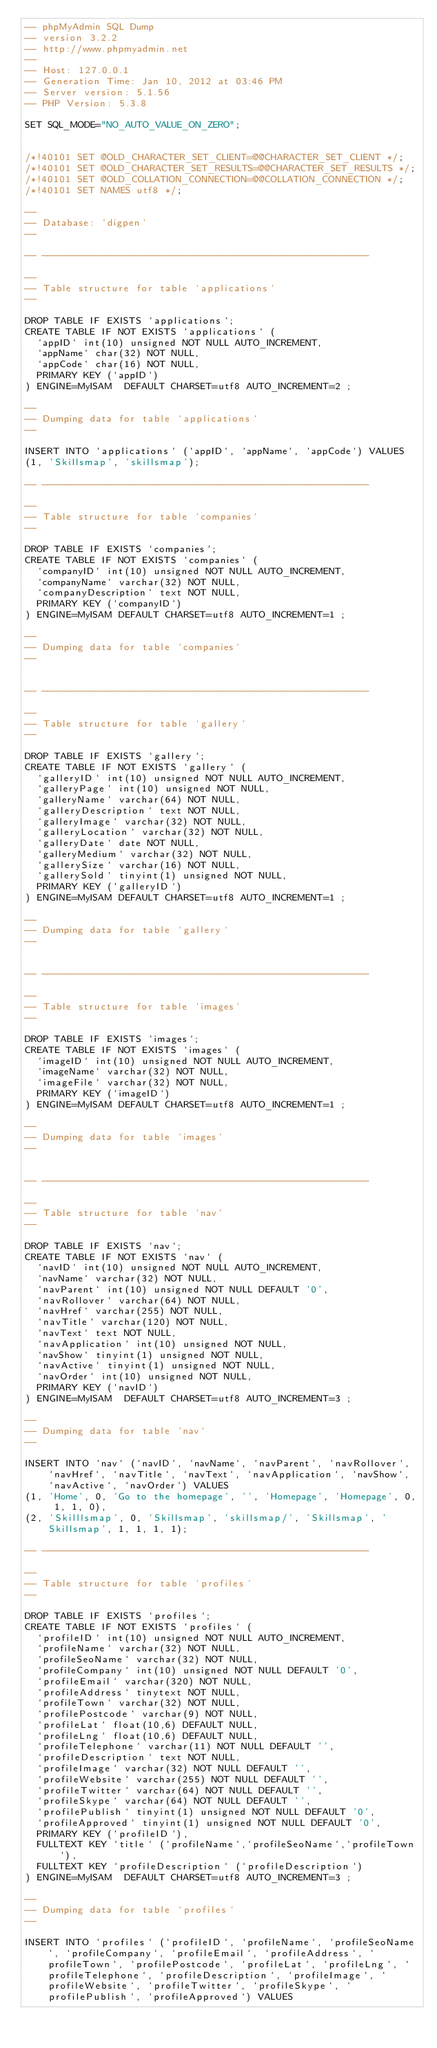Convert code to text. <code><loc_0><loc_0><loc_500><loc_500><_SQL_>-- phpMyAdmin SQL Dump
-- version 3.2.2
-- http://www.phpmyadmin.net
--
-- Host: 127.0.0.1
-- Generation Time: Jan 10, 2012 at 03:46 PM
-- Server version: 5.1.56
-- PHP Version: 5.3.8

SET SQL_MODE="NO_AUTO_VALUE_ON_ZERO";


/*!40101 SET @OLD_CHARACTER_SET_CLIENT=@@CHARACTER_SET_CLIENT */;
/*!40101 SET @OLD_CHARACTER_SET_RESULTS=@@CHARACTER_SET_RESULTS */;
/*!40101 SET @OLD_COLLATION_CONNECTION=@@COLLATION_CONNECTION */;
/*!40101 SET NAMES utf8 */;

--
-- Database: `digpen`
--

-- --------------------------------------------------------

--
-- Table structure for table `applications`
--

DROP TABLE IF EXISTS `applications`;
CREATE TABLE IF NOT EXISTS `applications` (
  `appID` int(10) unsigned NOT NULL AUTO_INCREMENT,
  `appName` char(32) NOT NULL,
  `appCode` char(16) NOT NULL,
  PRIMARY KEY (`appID`)
) ENGINE=MyISAM  DEFAULT CHARSET=utf8 AUTO_INCREMENT=2 ;

--
-- Dumping data for table `applications`
--

INSERT INTO `applications` (`appID`, `appName`, `appCode`) VALUES
(1, 'Skillsmap', 'skillsmap');

-- --------------------------------------------------------

--
-- Table structure for table `companies`
--

DROP TABLE IF EXISTS `companies`;
CREATE TABLE IF NOT EXISTS `companies` (
  `companyID` int(10) unsigned NOT NULL AUTO_INCREMENT,
  `companyName` varchar(32) NOT NULL,
  `companyDescription` text NOT NULL,
  PRIMARY KEY (`companyID`)
) ENGINE=MyISAM DEFAULT CHARSET=utf8 AUTO_INCREMENT=1 ;

--
-- Dumping data for table `companies`
--


-- --------------------------------------------------------

--
-- Table structure for table `gallery`
--

DROP TABLE IF EXISTS `gallery`;
CREATE TABLE IF NOT EXISTS `gallery` (
  `galleryID` int(10) unsigned NOT NULL AUTO_INCREMENT,
  `galleryPage` int(10) unsigned NOT NULL,
  `galleryName` varchar(64) NOT NULL,
  `galleryDescription` text NOT NULL,
  `galleryImage` varchar(32) NOT NULL,
  `galleryLocation` varchar(32) NOT NULL,
  `galleryDate` date NOT NULL,
  `galleryMedium` varchar(32) NOT NULL,
  `gallerySize` varchar(16) NOT NULL,
  `gallerySold` tinyint(1) unsigned NOT NULL,
  PRIMARY KEY (`galleryID`)
) ENGINE=MyISAM DEFAULT CHARSET=utf8 AUTO_INCREMENT=1 ;

--
-- Dumping data for table `gallery`
--


-- --------------------------------------------------------

--
-- Table structure for table `images`
--

DROP TABLE IF EXISTS `images`;
CREATE TABLE IF NOT EXISTS `images` (
  `imageID` int(10) unsigned NOT NULL AUTO_INCREMENT,
  `imageName` varchar(32) NOT NULL,
  `imageFile` varchar(32) NOT NULL,
  PRIMARY KEY (`imageID`)
) ENGINE=MyISAM DEFAULT CHARSET=utf8 AUTO_INCREMENT=1 ;

--
-- Dumping data for table `images`
--


-- --------------------------------------------------------

--
-- Table structure for table `nav`
--

DROP TABLE IF EXISTS `nav`;
CREATE TABLE IF NOT EXISTS `nav` (
  `navID` int(10) unsigned NOT NULL AUTO_INCREMENT,
  `navName` varchar(32) NOT NULL,
  `navParent` int(10) unsigned NOT NULL DEFAULT '0',
  `navRollover` varchar(64) NOT NULL,
  `navHref` varchar(255) NOT NULL,
  `navTitle` varchar(120) NOT NULL,
  `navText` text NOT NULL,
  `navApplication` int(10) unsigned NOT NULL,
  `navShow` tinyint(1) unsigned NOT NULL,
  `navActive` tinyint(1) unsigned NOT NULL,
  `navOrder` int(10) unsigned NOT NULL,
  PRIMARY KEY (`navID`)
) ENGINE=MyISAM  DEFAULT CHARSET=utf8 AUTO_INCREMENT=3 ;

--
-- Dumping data for table `nav`
--

INSERT INTO `nav` (`navID`, `navName`, `navParent`, `navRollover`, `navHref`, `navTitle`, `navText`, `navApplication`, `navShow`, `navActive`, `navOrder`) VALUES
(1, 'Home', 0, 'Go to the homepage', '', 'Homepage', 'Homepage', 0, 1, 1, 0),
(2, 'Skilllsmap', 0, 'Skillsmap', 'skillsmap/', 'Skillsmap', 'Skillsmap', 1, 1, 1, 1);

-- --------------------------------------------------------

--
-- Table structure for table `profiles`
--

DROP TABLE IF EXISTS `profiles`;
CREATE TABLE IF NOT EXISTS `profiles` (
  `profileID` int(10) unsigned NOT NULL AUTO_INCREMENT,
  `profileName` varchar(32) NOT NULL,
  `profileSeoName` varchar(32) NOT NULL,
  `profileCompany` int(10) unsigned NOT NULL DEFAULT '0',
  `profileEmail` varchar(320) NOT NULL,
  `profileAddress` tinytext NOT NULL,
  `profileTown` varchar(32) NOT NULL,
  `profilePostcode` varchar(9) NOT NULL,
  `profileLat` float(10,6) DEFAULT NULL,
  `profileLng` float(10,6) DEFAULT NULL,
  `profileTelephone` varchar(11) NOT NULL DEFAULT '',
  `profileDescription` text NOT NULL,
  `profileImage` varchar(32) NOT NULL DEFAULT '',
  `profileWebsite` varchar(255) NOT NULL DEFAULT '',
  `profileTwitter` varchar(64) NOT NULL DEFAULT '',
  `profileSkype` varchar(64) NOT NULL DEFAULT '',
  `profilePublish` tinyint(1) unsigned NOT NULL DEFAULT '0',
  `profileApproved` tinyint(1) unsigned NOT NULL DEFAULT '0',
  PRIMARY KEY (`profileID`),
  FULLTEXT KEY `title` (`profileName`,`profileSeoName`,`profileTown`),
  FULLTEXT KEY `profileDescription` (`profileDescription`)
) ENGINE=MyISAM  DEFAULT CHARSET=utf8 AUTO_INCREMENT=3 ;

--
-- Dumping data for table `profiles`
--

INSERT INTO `profiles` (`profileID`, `profileName`, `profileSeoName`, `profileCompany`, `profileEmail`, `profileAddress`, `profileTown`, `profilePostcode`, `profileLat`, `profileLng`, `profileTelephone`, `profileDescription`, `profileImage`, `profileWebsite`, `profileTwitter`, `profileSkype`, `profilePublish`, `profileApproved`) VALUES</code> 